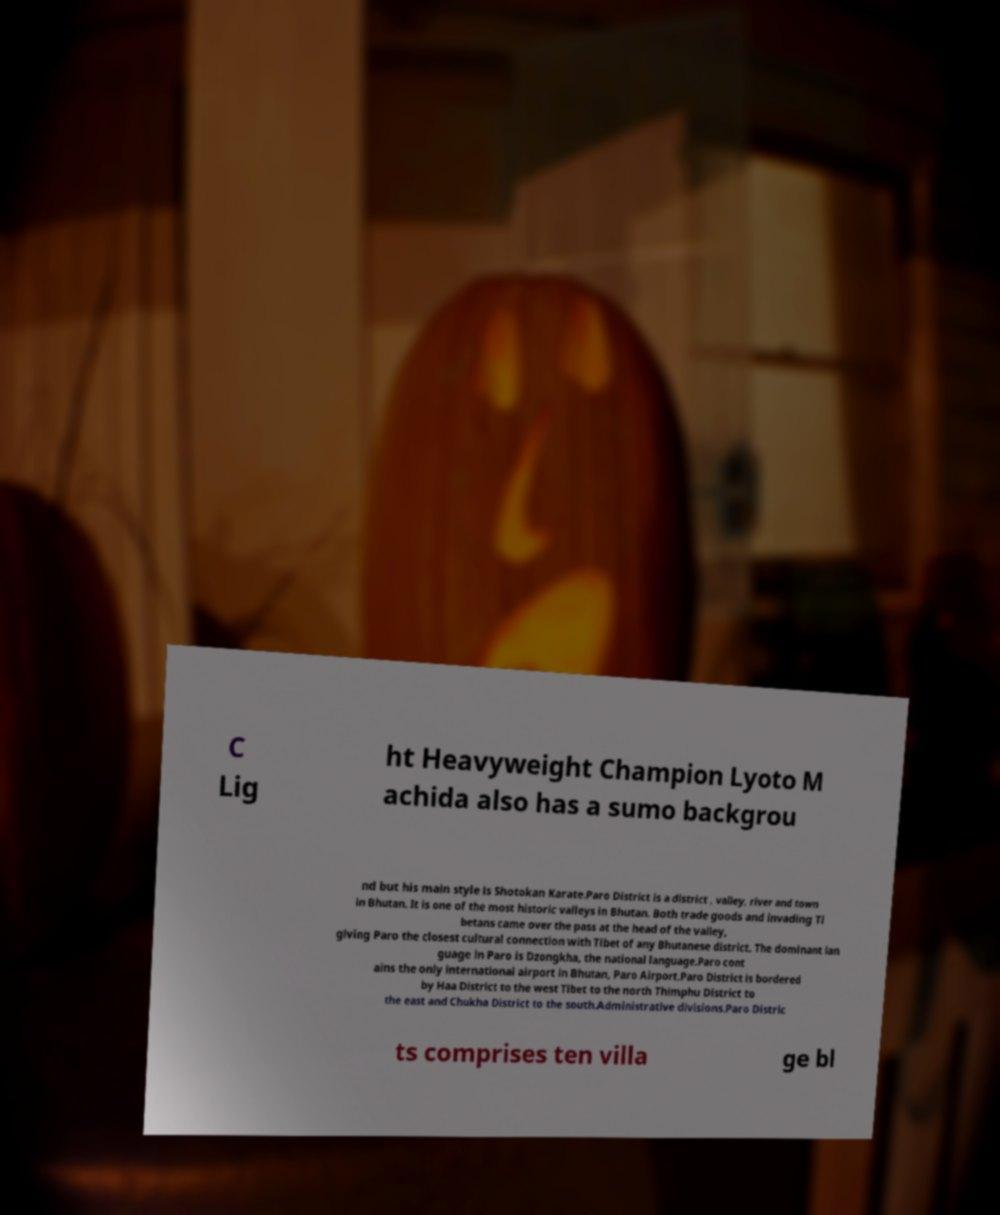Can you read and provide the text displayed in the image?This photo seems to have some interesting text. Can you extract and type it out for me? C Lig ht Heavyweight Champion Lyoto M achida also has a sumo backgrou nd but his main style is Shotokan Karate.Paro District is a district , valley, river and town in Bhutan. It is one of the most historic valleys in Bhutan. Both trade goods and invading Ti betans came over the pass at the head of the valley, giving Paro the closest cultural connection with Tibet of any Bhutanese district. The dominant lan guage in Paro is Dzongkha, the national language.Paro cont ains the only international airport in Bhutan, Paro Airport.Paro District is bordered by Haa District to the west Tibet to the north Thimphu District to the east and Chukha District to the south.Administrative divisions.Paro Distric ts comprises ten villa ge bl 